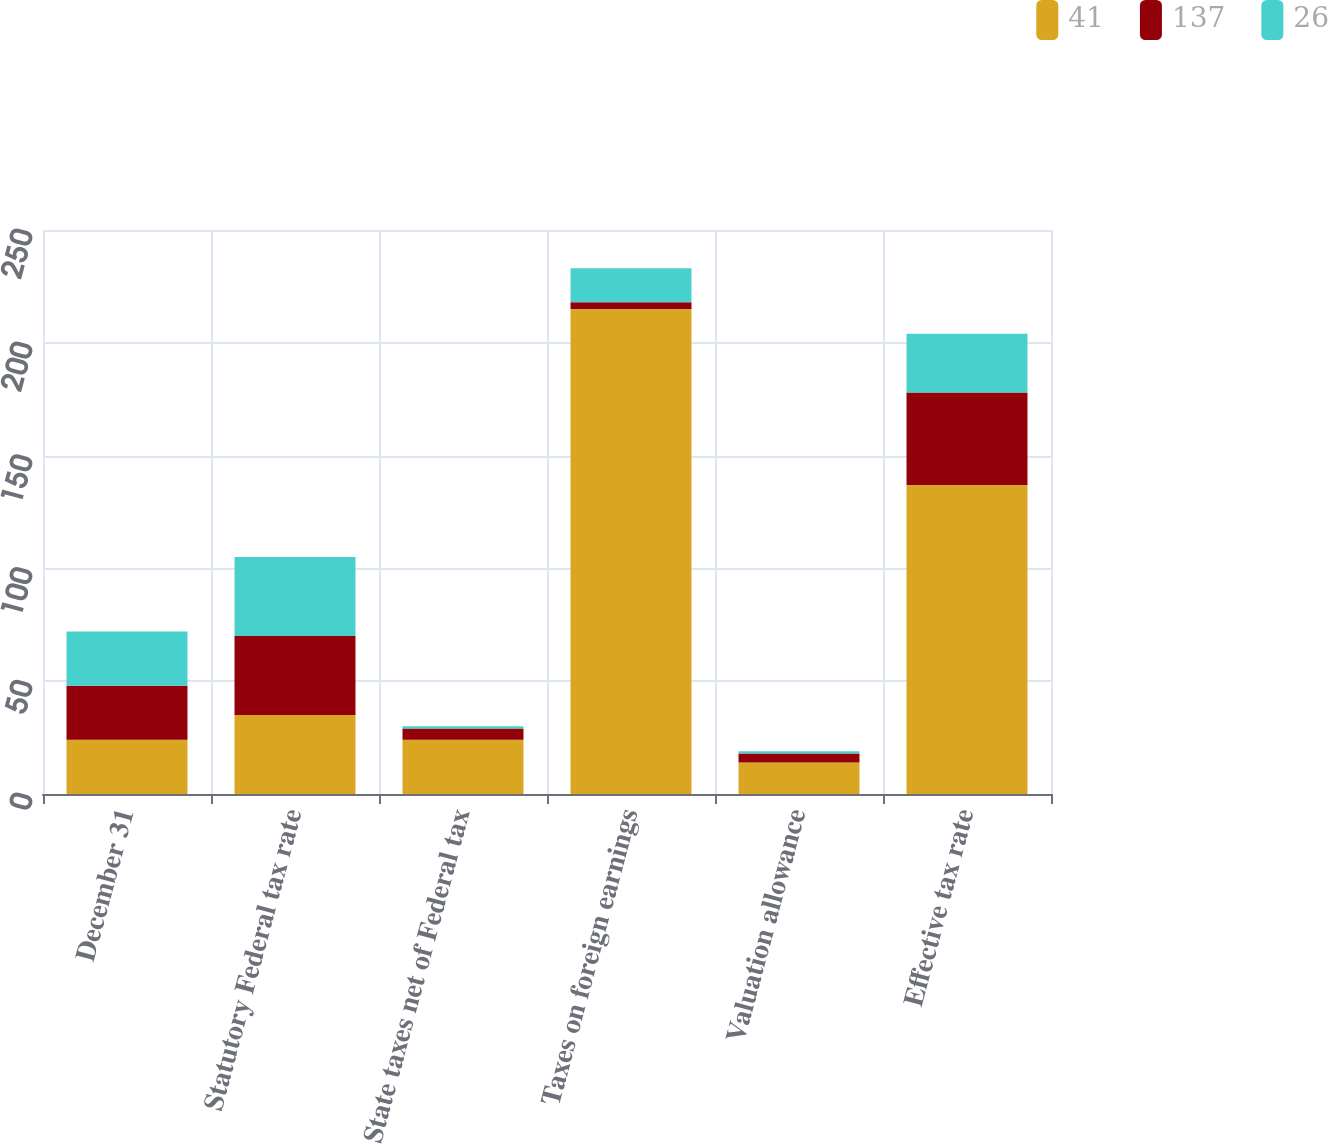<chart> <loc_0><loc_0><loc_500><loc_500><stacked_bar_chart><ecel><fcel>December 31<fcel>Statutory Federal tax rate<fcel>State taxes net of Federal tax<fcel>Taxes on foreign earnings<fcel>Valuation allowance<fcel>Effective tax rate<nl><fcel>41<fcel>24<fcel>35<fcel>24<fcel>215<fcel>14<fcel>137<nl><fcel>137<fcel>24<fcel>35<fcel>5<fcel>3<fcel>4<fcel>41<nl><fcel>26<fcel>24<fcel>35<fcel>1<fcel>15<fcel>1<fcel>26<nl></chart> 